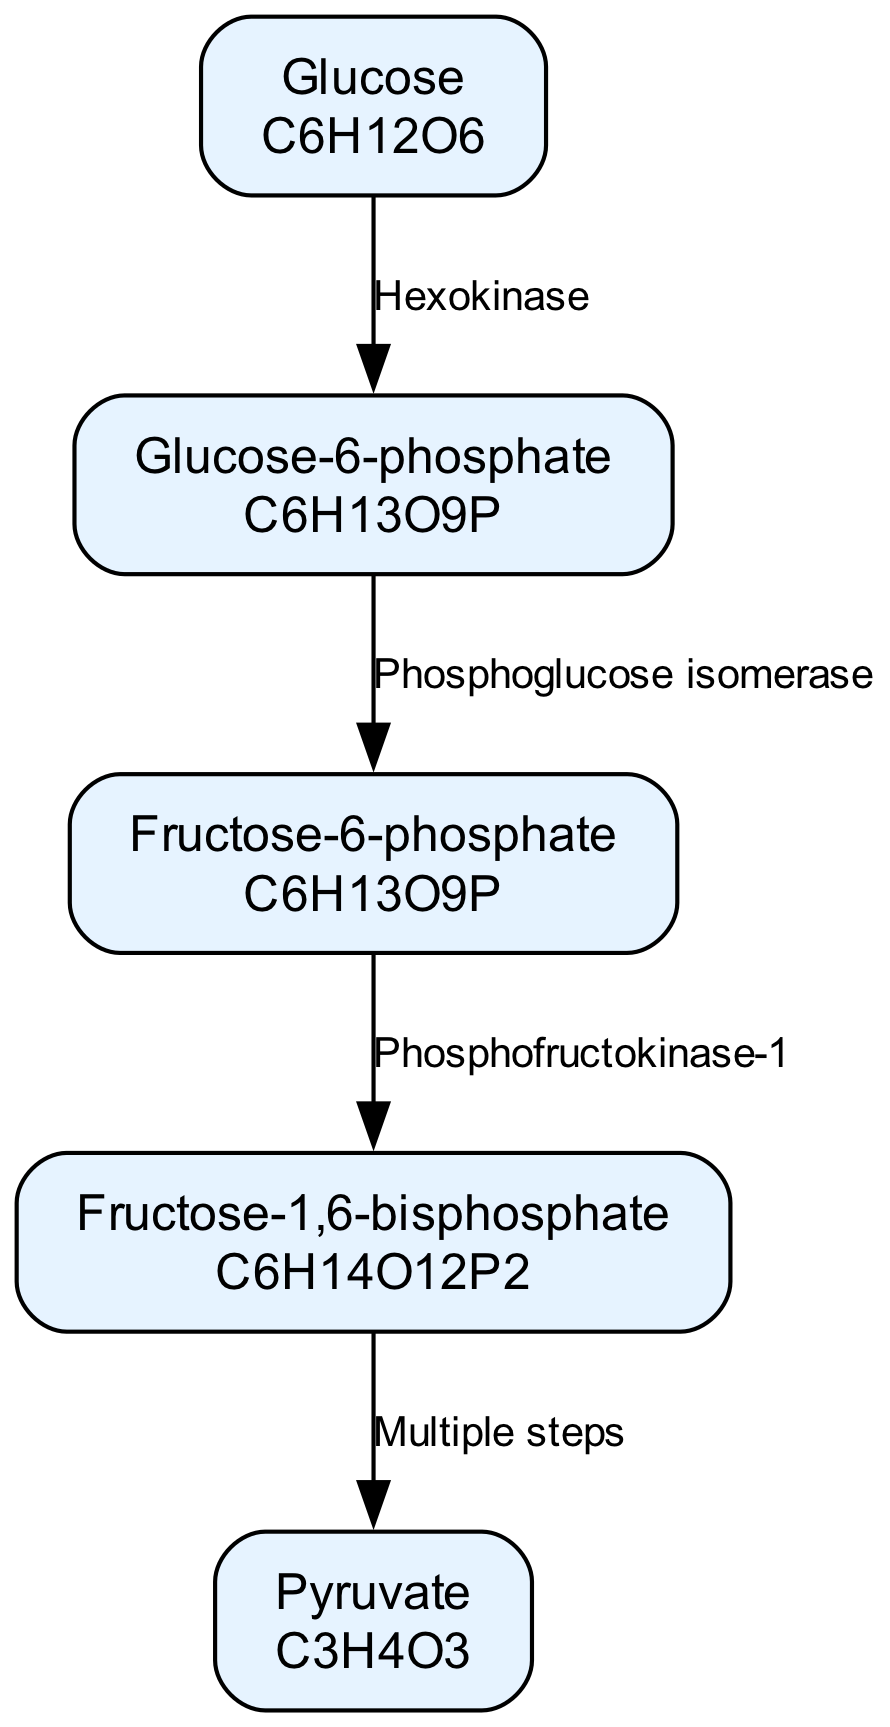What is the first metabolite in the glycolysis pathway? The diagram starts with "Glucose" as the first metabolite listed, indicated by its position at the top and connections in the pathway.
Answer: Glucose How many metabolites are shown in the diagram? The diagram lists five metabolites: Glucose, Glucose-6-phosphate, Fructose-6-phosphate, Fructose-1,6-bisphosphate, and Pyruvate. Counting these gives a total of five.
Answer: 5 What enzyme converts Glucose to Glucose-6-phosphate? The edge from "Glucose" to "Glucose-6-phosphate" is labeled with the enzyme "Hexokinase", showing it is the catalyst for this reaction.
Answer: Hexokinase Which metabolite is directly converted into Pyruvate? Tracing the pathway from "Fructose-1,6-bisphosphate", the edge labeled "Multiple steps" indicates that it leads directly to "Pyruvate."
Answer: Fructose-1,6-bisphosphate What is the structure of Glucose-6-phosphate? The diagram includes the structure of Glucose-6-phosphate listed as "C6H13O9P" directly beneath its label in the node.
Answer: C6H13O9P Which enzyme links Fructose-6-phosphate to Fructose-1,6-bisphosphate? The arrow from "Fructose-6-phosphate" to "Fructose-1,6-bisphosphate" is marked with the enzyme "Phosphofructokinase-1", showing its role in this conversion.
Answer: Phosphofructokinase-1 What is the overall direction of the glycolysis pathway represented in this diagram? The nodes and edges flow from "Glucose" at the top to "Pyruvate" at the bottom, indicating a downward or unidirectional pathway from start to end.
Answer: Downward Which three metabolites are involved in the connection from Glucose to Pyruvate? The pathway connections trace through Glucose to Glucose-6-phosphate, then to Fructose-6-phosphate, and finally to Fructose-1,6-bisphosphate before reaching Pyruvate.
Answer: Glucose, Glucose-6-phosphate, Fructose-6-phosphate 